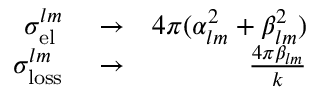Convert formula to latex. <formula><loc_0><loc_0><loc_500><loc_500>\begin{array} { r l r } { \sigma _ { e l } ^ { l m } } & \to } & { 4 \pi ( \alpha _ { l m } ^ { 2 } + \beta _ { l m } ^ { 2 } ) } \\ { \sigma _ { l o s s } ^ { l m } } & \to } & { \frac { 4 \pi \beta _ { l m } } { k } } \end{array}</formula> 